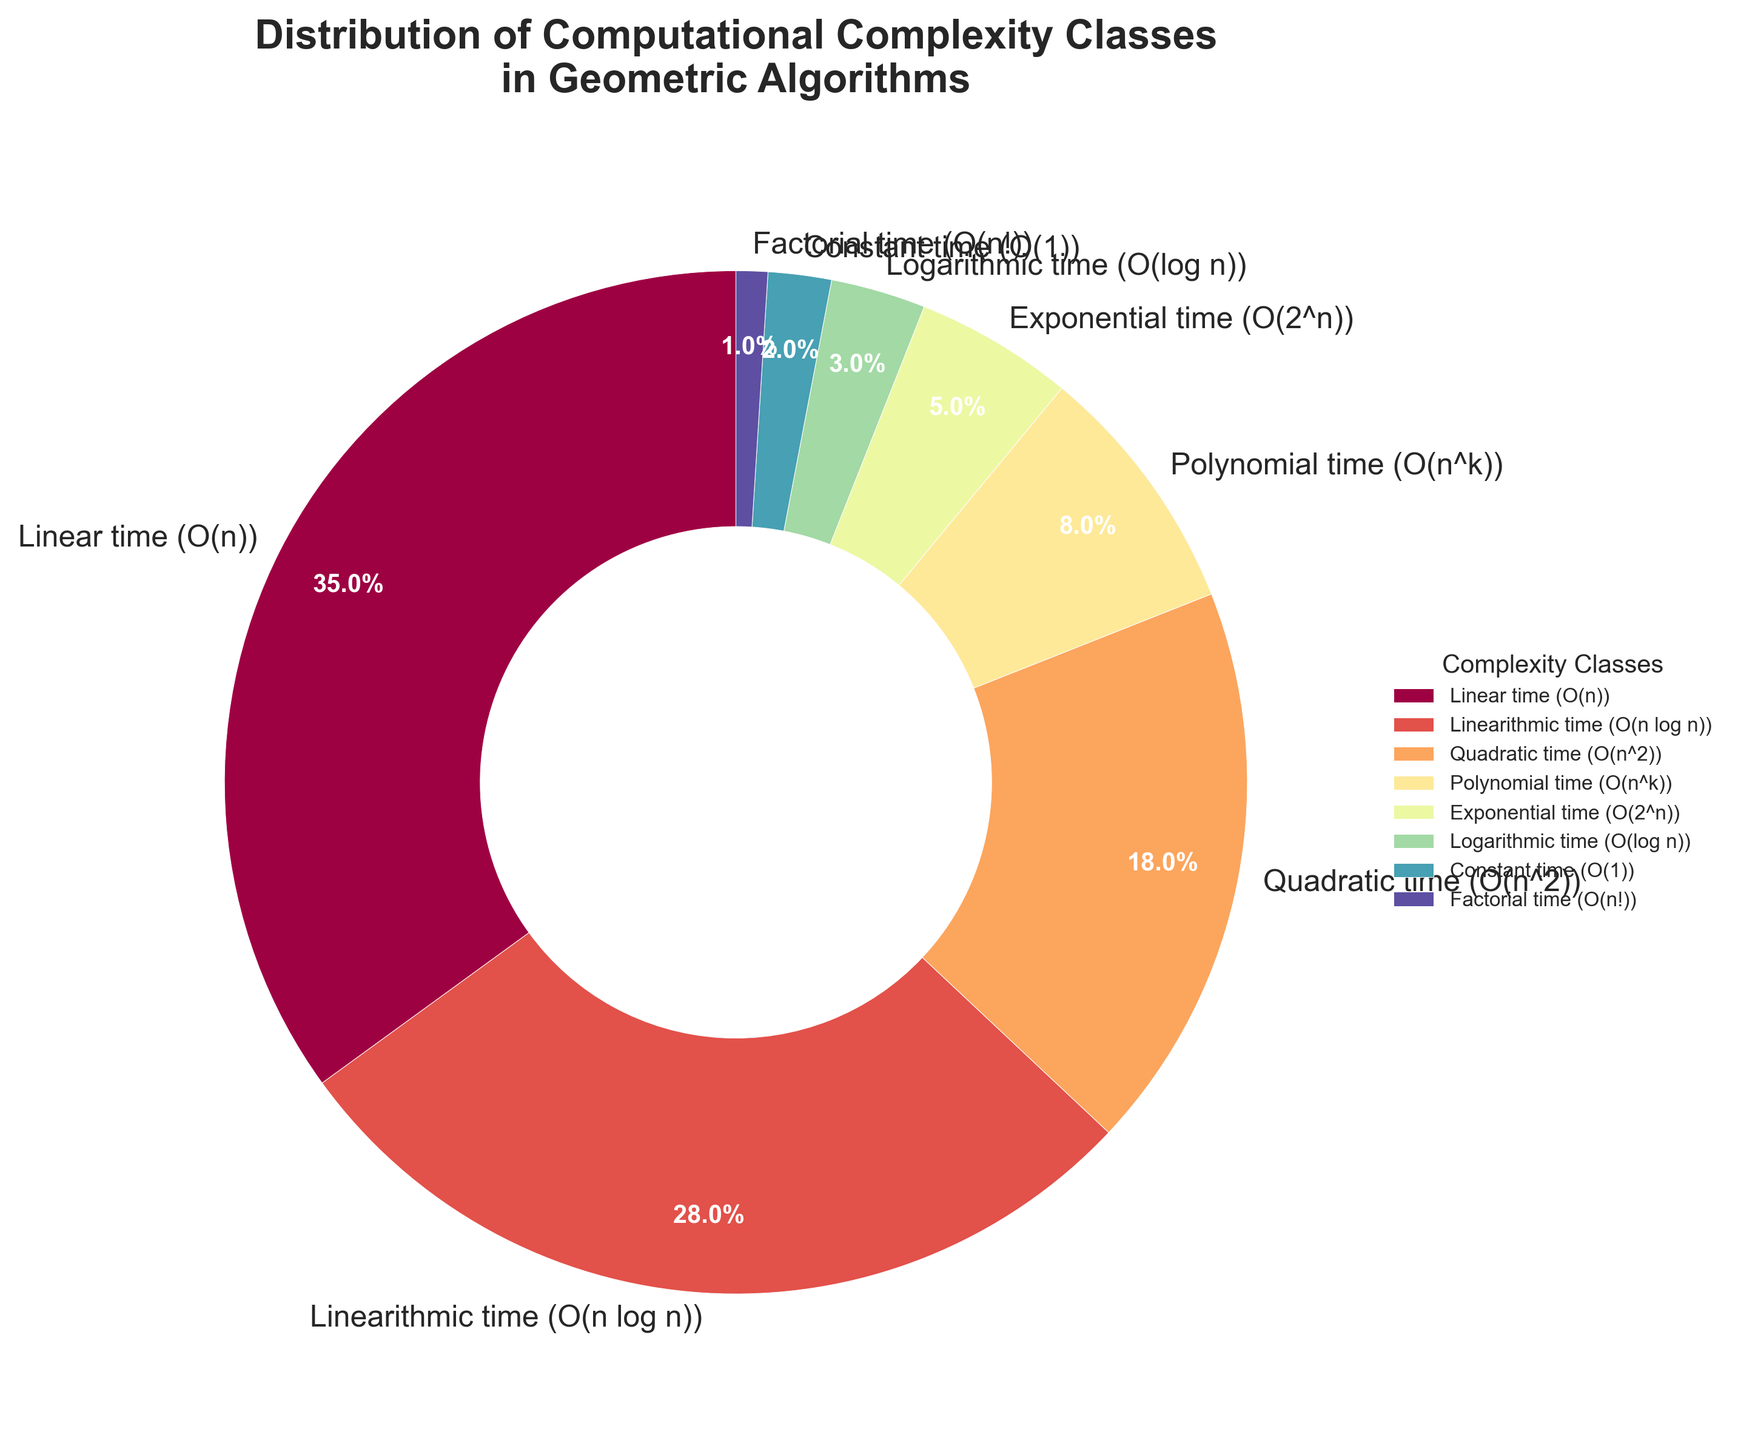Which complexity class has the largest share in the distribution? Linear time (O(n)) has the largest slice in the pie chart, corresponding to 35%. This is the highest percentage among the presented complexity classes.
Answer: Linear time (O(n)) How much larger is the Linearithmic time class compared to the Quadratic time class? Linearithmic time (O(n log n)) is 28%, and Quadratic time (O(n^2)) is 18%. The difference is 28% - 18% = 10%.
Answer: 10% Which complexity classes together make up more than half of the distribution? Linear time (35%) and Linearithmic time (28%) can be summed together: 35% + 28% = 63%. This is more than 50%.
Answer: Linear time (O(n)) and Linearithmic time (O(n log n)) What's the combined percentage of Polynomial and Exponential time classes? Polynomial time (O(n^k)) is 8% and Exponential time (O(2^n)) is 5%. Adding these together: 8% + 5% = 13%.
Answer: 13% Which complexity class has the smallest representation in the distribution? The slice for Factorial time (O(n!)) is 1%, which is the smallest percentage shown in the chart.
Answer: Factorial time (O(n!)) What is the percentage difference between the class with the smallest representation and the class with the largest representation? The largest percentage is 35% for Linear time (O(n)), and the smallest is 1% for Factorial time (O(n!)). The difference is 35% - 1% = 34%.
Answer: 34% How does the percentage of Logarithmic time compare to Constant time? Logarithmic time (O(log n)) has 3%, and Constant time (O(1)) has 2%. Logarithmic time is 3% - 2% = 1% more than Constant time.
Answer: 1% What is the total percentage represented by classes with polynomial or worse complexities (Quadratic, Polynomial, Exponential, Factorial)? Quadratic (18%) + Polynomial (8%) + Exponential (5%) + Factorial (1%) = 18% + 8% + 5% + 1% = 32%.
Answer: 32% Describe the visual difference between the slices representing Linearithmic time and Exponential time. The Linearithmic time (O(n log n)) slice is significantly larger and more prominent, filling more space in the chart, whereas the Exponential time (O(2^n)) slice is much smaller and less visually dominant.
Answer: Linearithmic time slice is larger 